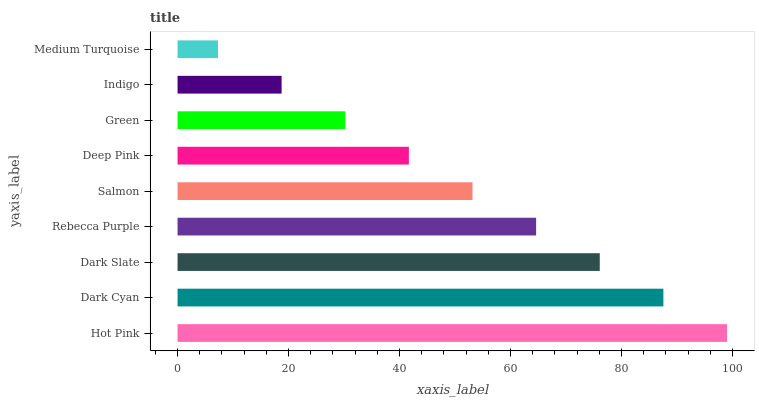Is Medium Turquoise the minimum?
Answer yes or no. Yes. Is Hot Pink the maximum?
Answer yes or no. Yes. Is Dark Cyan the minimum?
Answer yes or no. No. Is Dark Cyan the maximum?
Answer yes or no. No. Is Hot Pink greater than Dark Cyan?
Answer yes or no. Yes. Is Dark Cyan less than Hot Pink?
Answer yes or no. Yes. Is Dark Cyan greater than Hot Pink?
Answer yes or no. No. Is Hot Pink less than Dark Cyan?
Answer yes or no. No. Is Salmon the high median?
Answer yes or no. Yes. Is Salmon the low median?
Answer yes or no. Yes. Is Medium Turquoise the high median?
Answer yes or no. No. Is Hot Pink the low median?
Answer yes or no. No. 